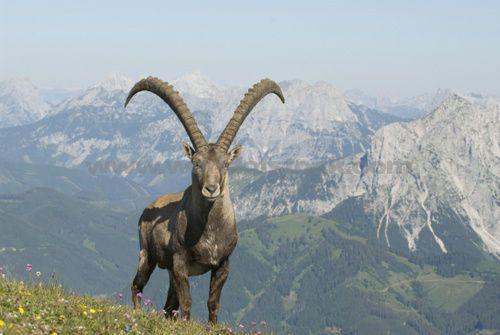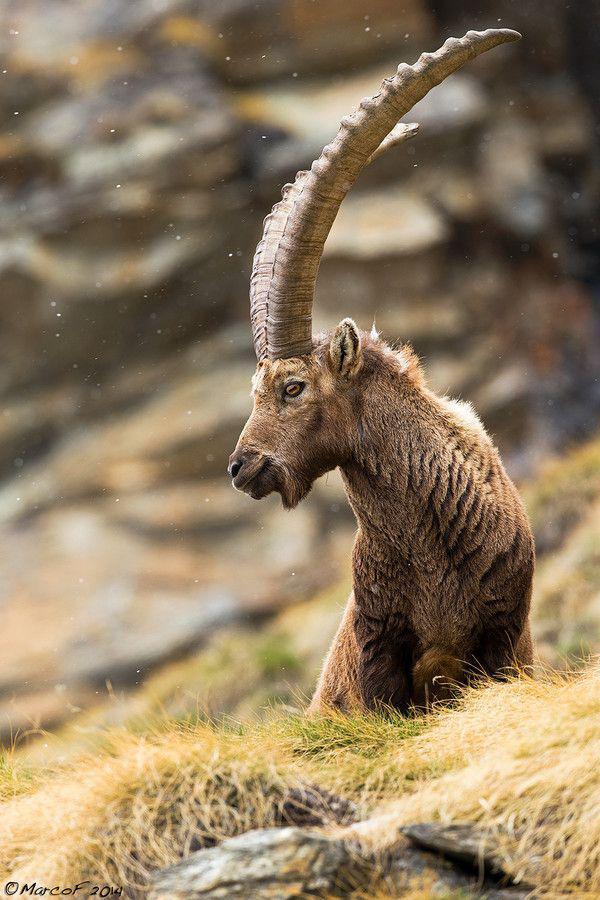The first image is the image on the left, the second image is the image on the right. Evaluate the accuracy of this statement regarding the images: "An image shows one camera-facing long-horned animal with an upright head, with mountain peaks in the background.". Is it true? Answer yes or no. Yes. The first image is the image on the left, the second image is the image on the right. Analyze the images presented: Is the assertion "A horned animal is posed with a view of the mountains behind it." valid? Answer yes or no. Yes. 